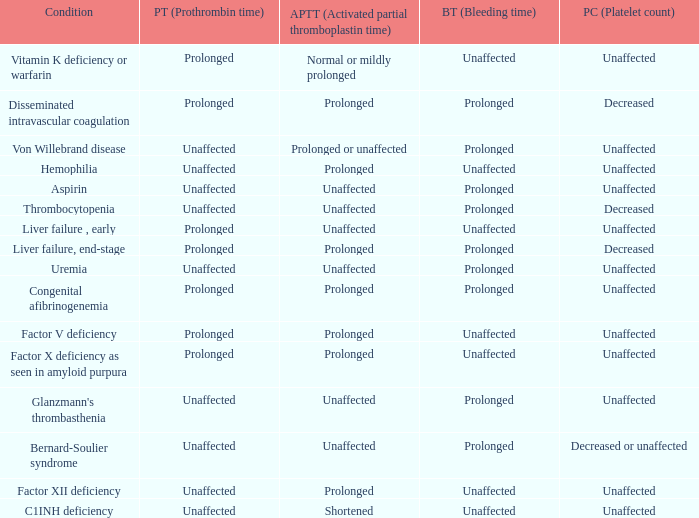Which Prothrombin time has a Platelet count of unaffected, and a Bleeding time of unaffected, and a Partial thromboplastin time of normal or mildly prolonged? Prolonged. 